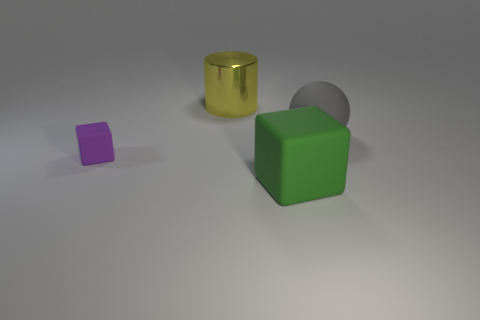Add 2 green blocks. How many objects exist? 6 Subtract all purple cubes. How many cubes are left? 1 Subtract 0 blue blocks. How many objects are left? 4 Subtract all cylinders. How many objects are left? 3 Subtract 1 cylinders. How many cylinders are left? 0 Subtract all red balls. Subtract all cyan cylinders. How many balls are left? 1 Subtract all cyan balls. How many purple cubes are left? 1 Subtract all tiny green matte balls. Subtract all rubber balls. How many objects are left? 3 Add 4 big yellow cylinders. How many big yellow cylinders are left? 5 Add 3 big cyan matte blocks. How many big cyan matte blocks exist? 3 